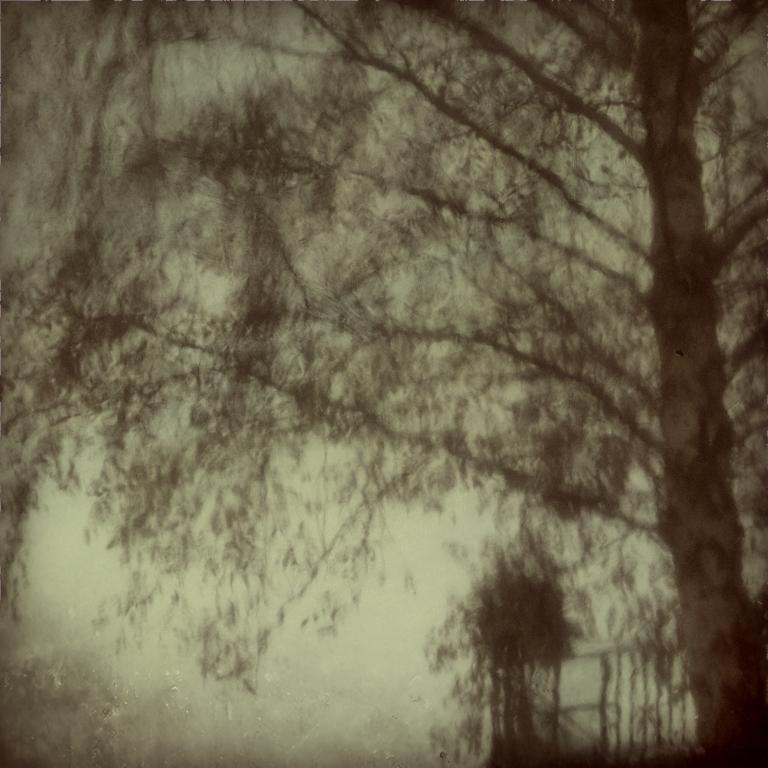Could you give a brief overview of what you see in this image? In the image there is a tree on the right side and the background is dark and blur. 